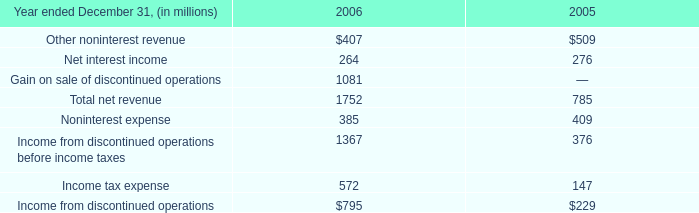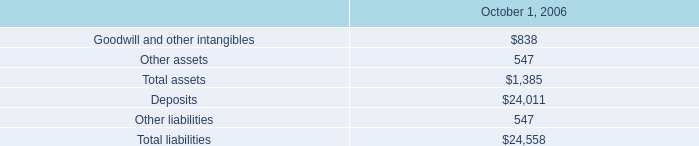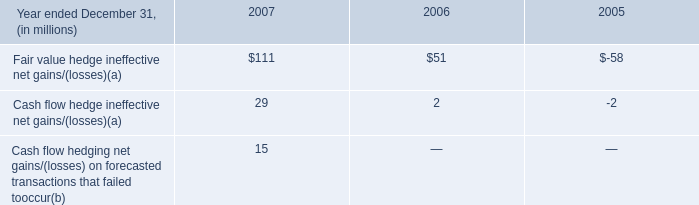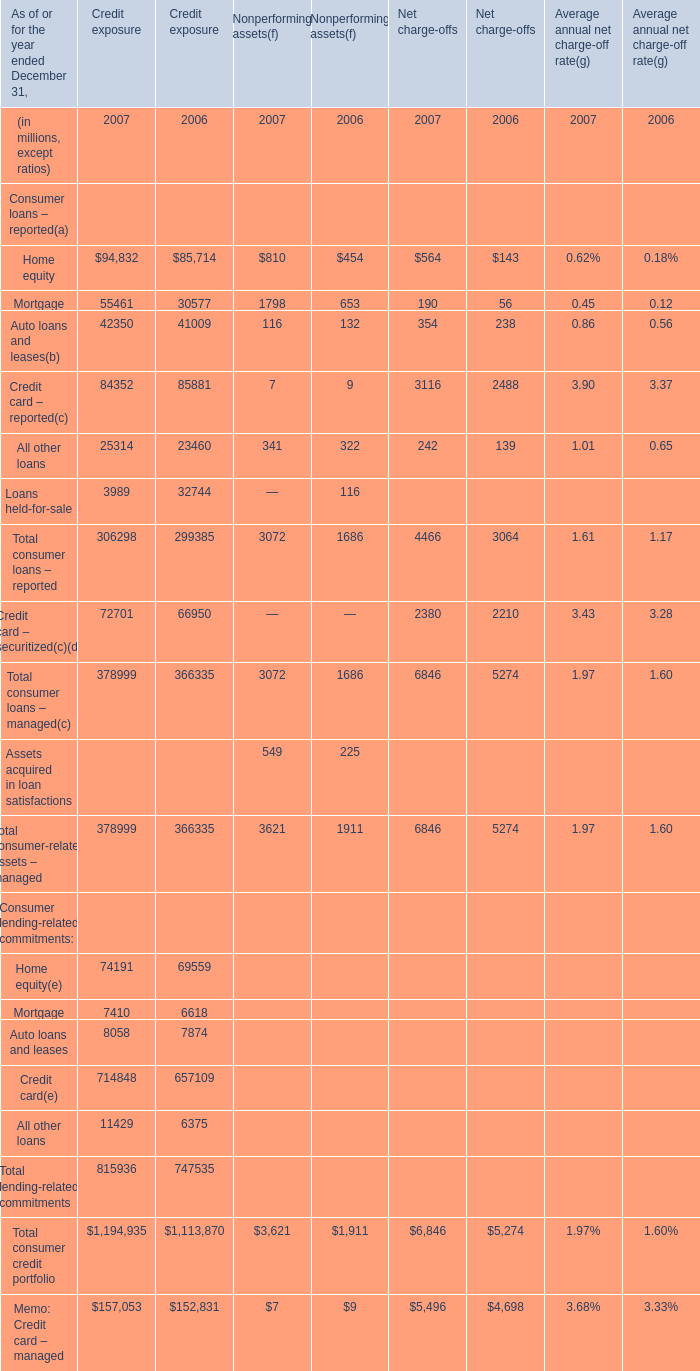If Mortgage for Nonperforming assets develops with the same growth rate in 2007, what will it reach in 2008? (in million) 
Computations: ((1 + ((1798 - 653) / 653)) * 1798)
Answer: 4950.69525. 